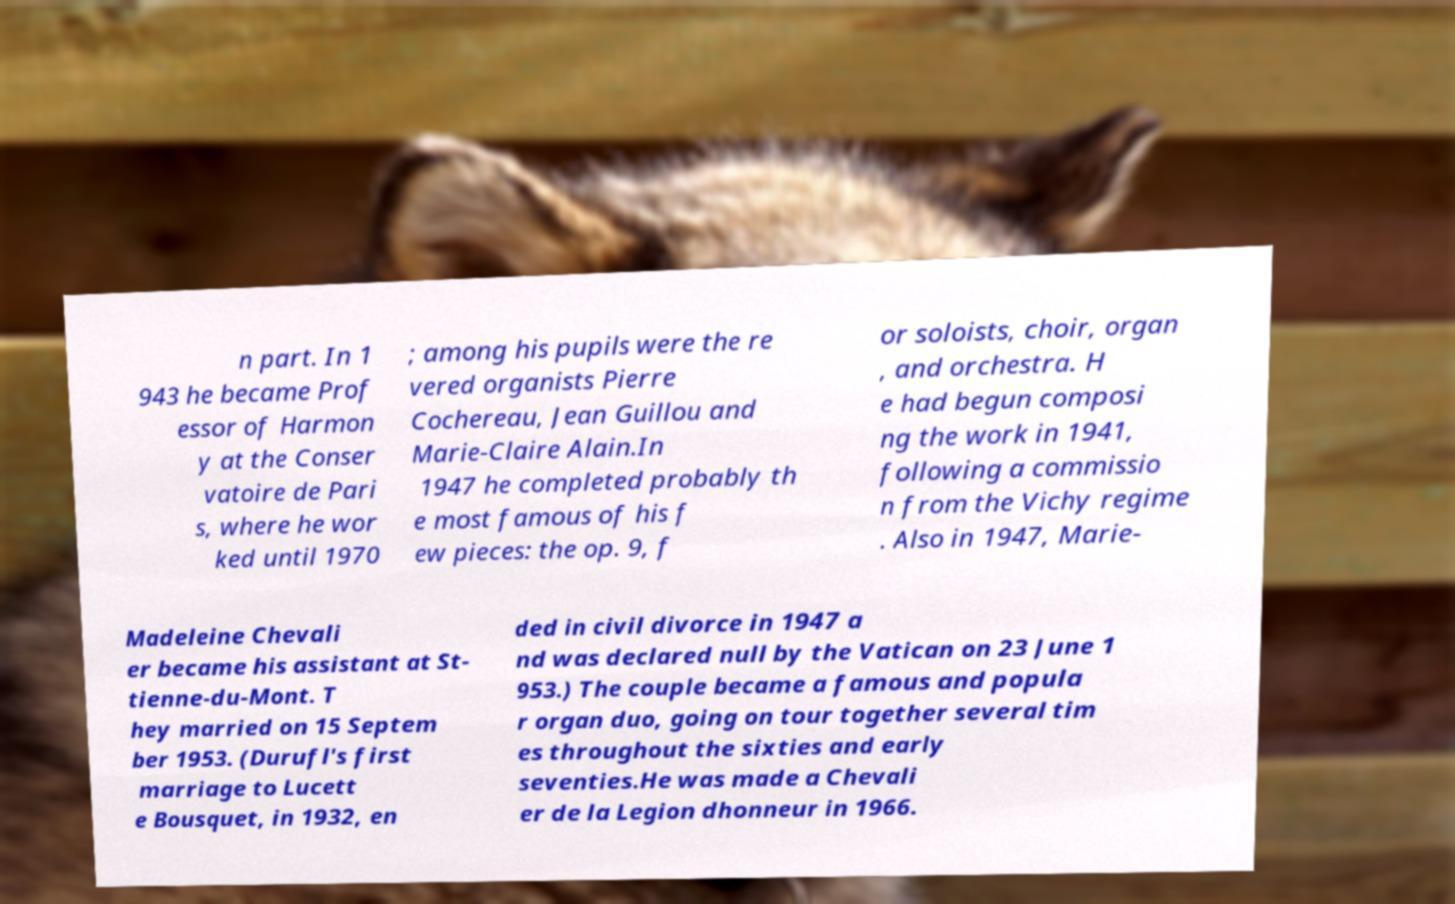For documentation purposes, I need the text within this image transcribed. Could you provide that? n part. In 1 943 he became Prof essor of Harmon y at the Conser vatoire de Pari s, where he wor ked until 1970 ; among his pupils were the re vered organists Pierre Cochereau, Jean Guillou and Marie-Claire Alain.In 1947 he completed probably th e most famous of his f ew pieces: the op. 9, f or soloists, choir, organ , and orchestra. H e had begun composi ng the work in 1941, following a commissio n from the Vichy regime . Also in 1947, Marie- Madeleine Chevali er became his assistant at St- tienne-du-Mont. T hey married on 15 Septem ber 1953. (Durufl's first marriage to Lucett e Bousquet, in 1932, en ded in civil divorce in 1947 a nd was declared null by the Vatican on 23 June 1 953.) The couple became a famous and popula r organ duo, going on tour together several tim es throughout the sixties and early seventies.He was made a Chevali er de la Legion dhonneur in 1966. 